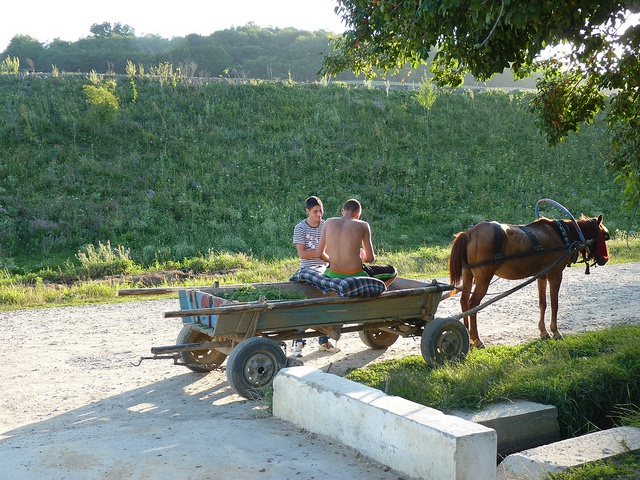Describe the objects in this image and their specific colors. I can see horse in white, black, maroon, and gray tones, people in white, gray, black, and darkgray tones, and people in white, darkgray, brown, and gray tones in this image. 